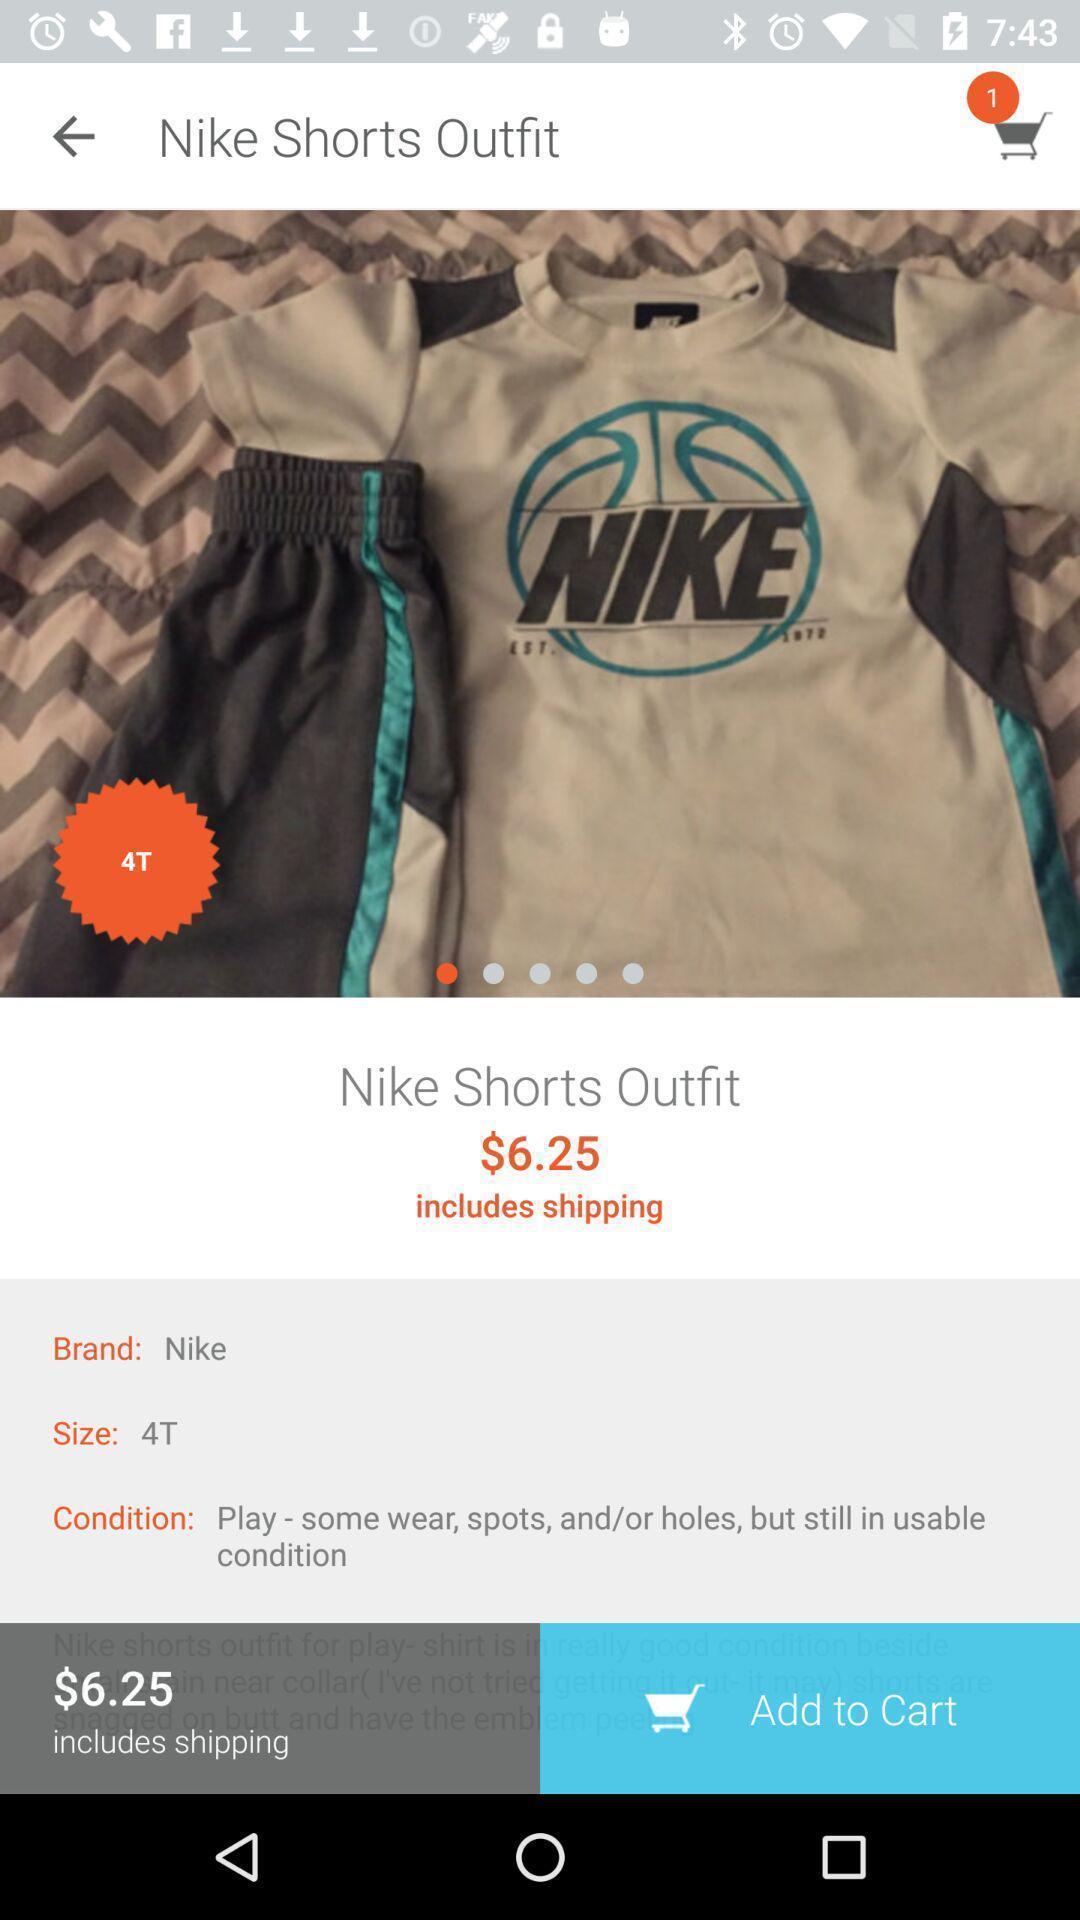Provide a detailed account of this screenshot. Screen shows product details in a shopping application. 